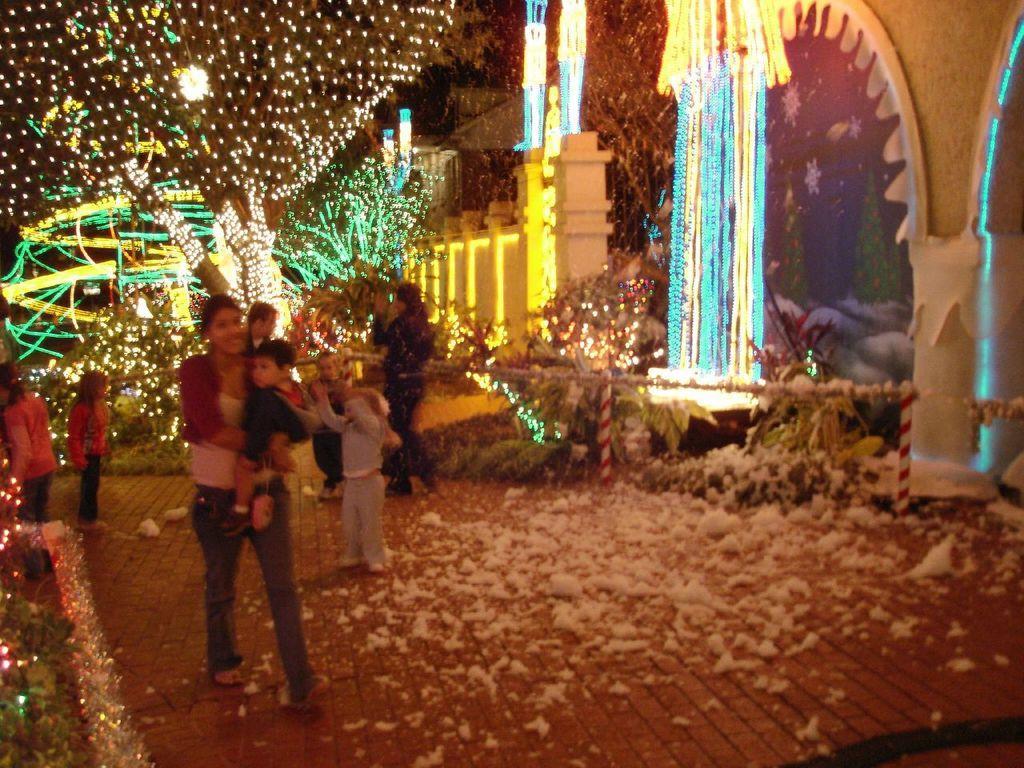In one or two sentences, can you explain what this image depicts? In this picture, we see a woman in the white T-shirt is holding a boy in her hands and she is smiling. At the bottom, we see the pavement. Behind her, we see the people are standing. On the left side, we see the trees which are decorated with the lights. On the right side, we see the pillars and a building, which is decorated with the lights. In the background, we see the trees which are decorated with the lights. This picture might be clicked in the dark. 